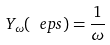<formula> <loc_0><loc_0><loc_500><loc_500>Y _ { \omega } ( \ e p s ) = \frac { 1 } { \omega }</formula> 